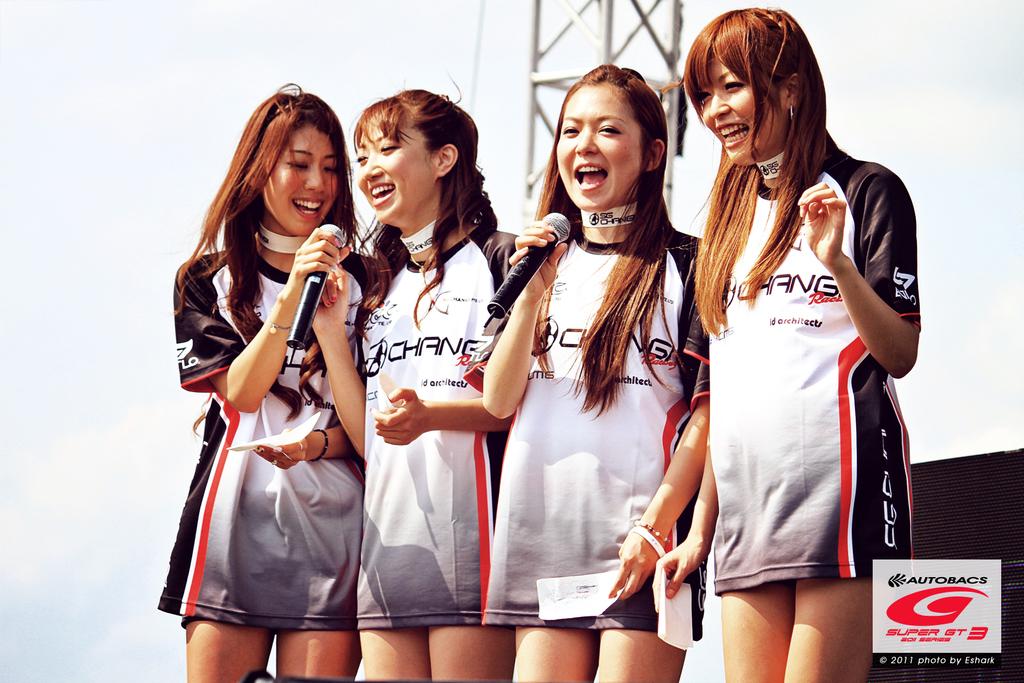What organization is sponsoring this event that is on the women's dresses?
Your response must be concise. Chang. What event is this for?
Provide a short and direct response. Unanswerable. 